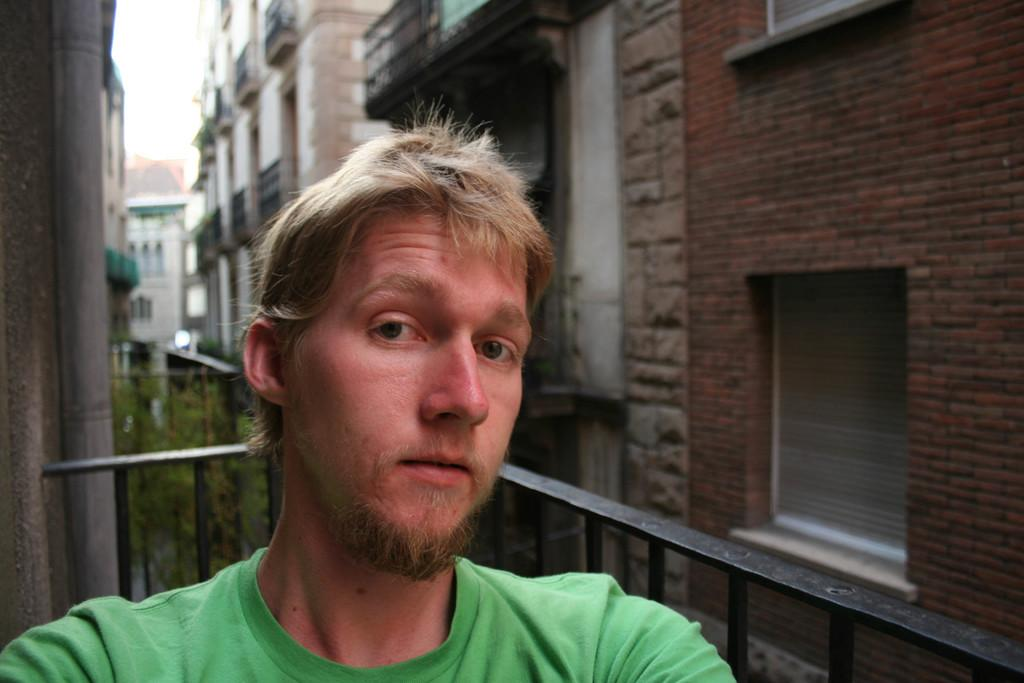What is the main subject in the foreground of the image? There is a man in the foreground of the image. What is the man wearing in the image? The man is wearing a green T-shirt. What can be seen in the background of the image? There are buildings, a railing, plants, and the sky visible in the background of the image. What type of stamp can be seen on the man's green T-shirt in the image? There is no stamp visible on the man's green T-shirt in the image. 